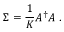Convert formula to latex. <formula><loc_0><loc_0><loc_500><loc_500>\Sigma = \frac { 1 } { K } A ^ { \dag } A \ .</formula> 